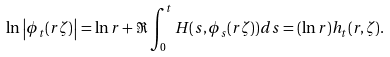Convert formula to latex. <formula><loc_0><loc_0><loc_500><loc_500>\ln \left | \phi _ { t } ( r \zeta ) \right | = \ln r + \Re \int _ { 0 } ^ { t } H ( s , \phi _ { s } ( r \zeta ) ) d s = ( \ln r ) h _ { t } ( r , \zeta ) .</formula> 